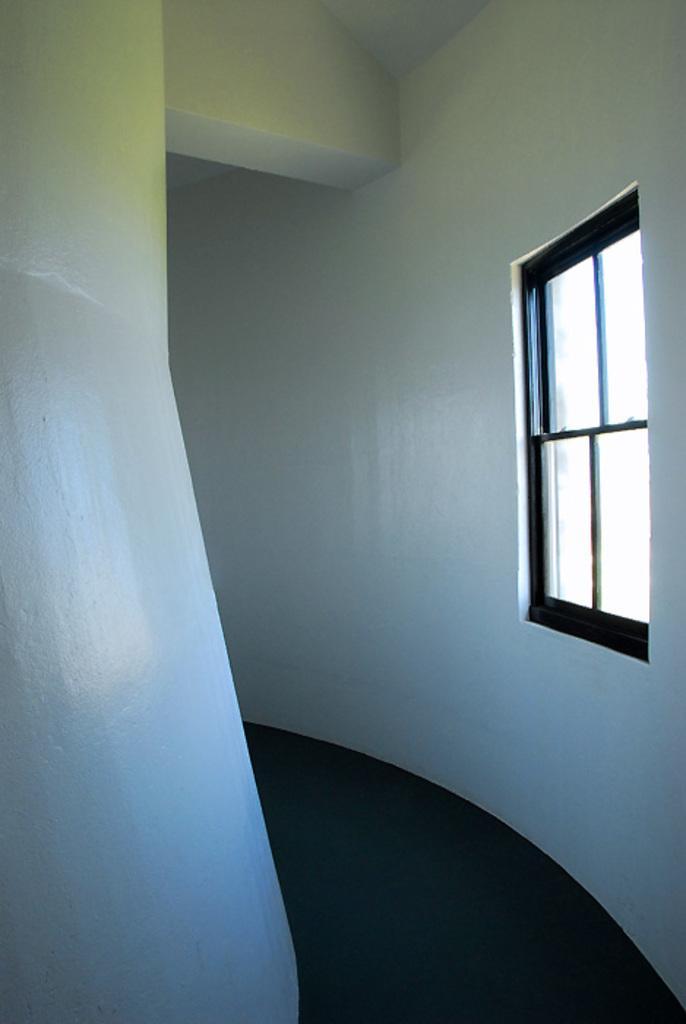Could you give a brief overview of what you see in this image? The image is taken in the room. On the right side of the image there is a window. In the background we can see a wall. 